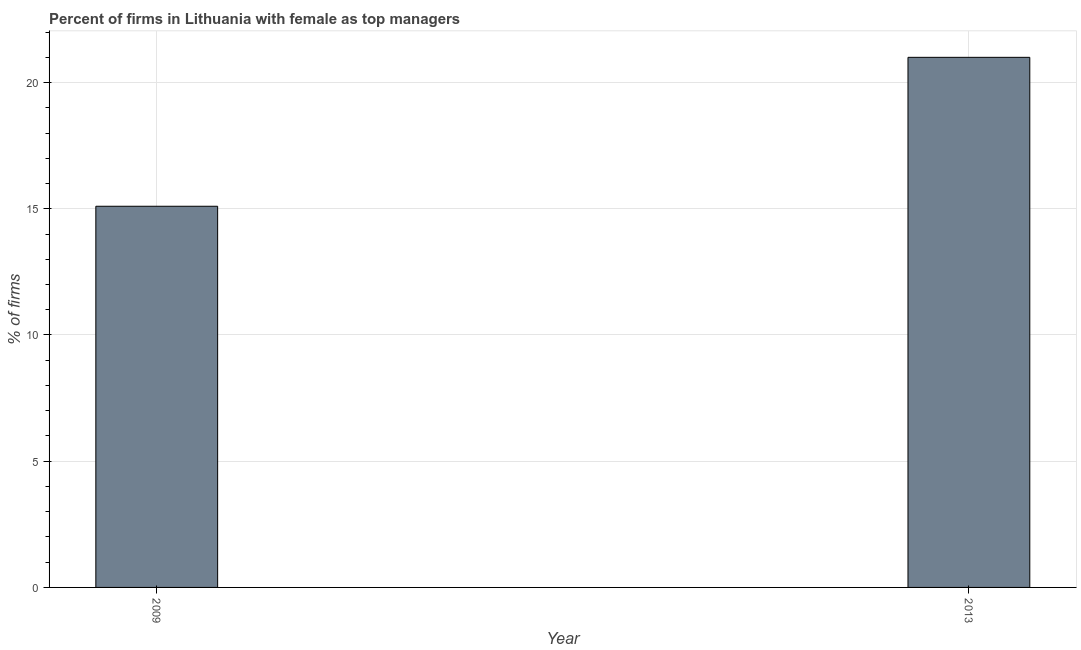What is the title of the graph?
Your response must be concise. Percent of firms in Lithuania with female as top managers. What is the label or title of the Y-axis?
Keep it short and to the point. % of firms. What is the percentage of firms with female as top manager in 2013?
Ensure brevity in your answer.  21. Across all years, what is the minimum percentage of firms with female as top manager?
Give a very brief answer. 15.1. What is the sum of the percentage of firms with female as top manager?
Offer a terse response. 36.1. What is the average percentage of firms with female as top manager per year?
Your response must be concise. 18.05. What is the median percentage of firms with female as top manager?
Your answer should be compact. 18.05. In how many years, is the percentage of firms with female as top manager greater than 16 %?
Your answer should be very brief. 1. Do a majority of the years between 2009 and 2013 (inclusive) have percentage of firms with female as top manager greater than 8 %?
Provide a succinct answer. Yes. What is the ratio of the percentage of firms with female as top manager in 2009 to that in 2013?
Make the answer very short. 0.72. Is the percentage of firms with female as top manager in 2009 less than that in 2013?
Offer a terse response. Yes. How many bars are there?
Your response must be concise. 2. Are all the bars in the graph horizontal?
Keep it short and to the point. No. How many years are there in the graph?
Make the answer very short. 2. What is the difference between two consecutive major ticks on the Y-axis?
Make the answer very short. 5. What is the % of firms in 2009?
Your response must be concise. 15.1. What is the % of firms of 2013?
Offer a very short reply. 21. What is the ratio of the % of firms in 2009 to that in 2013?
Offer a very short reply. 0.72. 